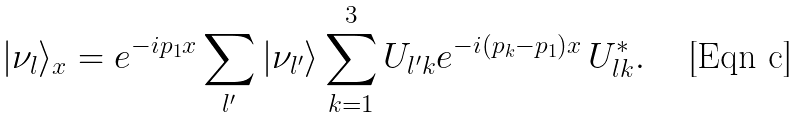Convert formula to latex. <formula><loc_0><loc_0><loc_500><loc_500>| \nu _ { l } \rangle _ { x } = e ^ { - i p _ { 1 } x } \sum _ { l ^ { \prime } } | \nu _ { l ^ { \prime } } \rangle \sum ^ { 3 } _ { k = 1 } U _ { l ^ { \prime } k } e ^ { - i ( p _ { k } - p _ { 1 } ) x } \, U _ { l k } ^ { * } .</formula> 